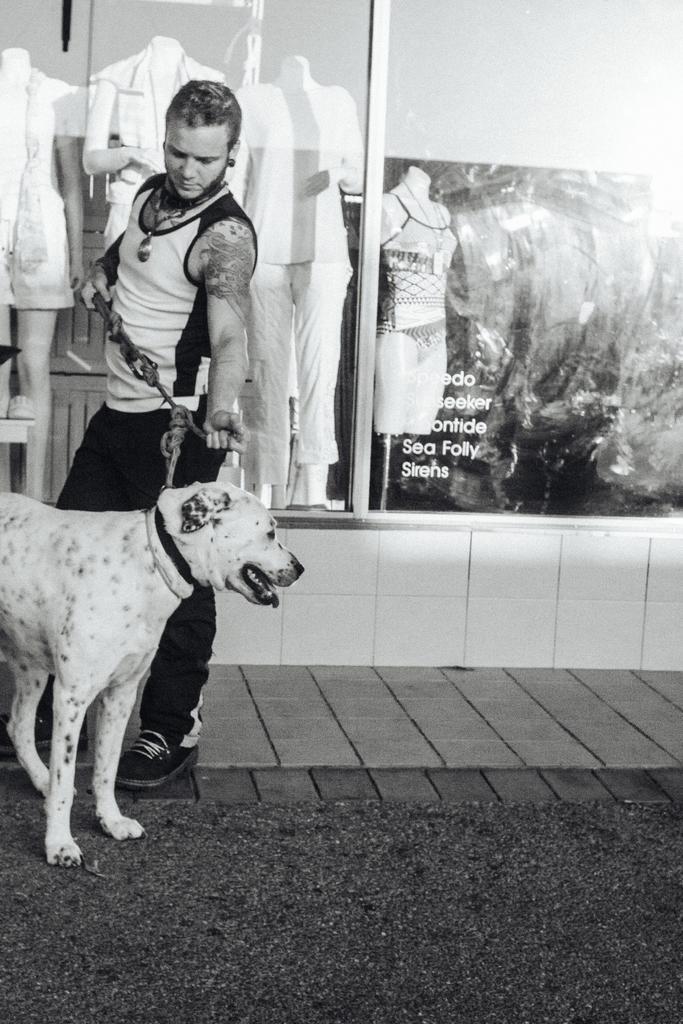Could you give a brief overview of what you see in this image? This is a black and white picture. In this picture we can see a man holding a belt of a dog. On the background we can see mannequins and clothes. 